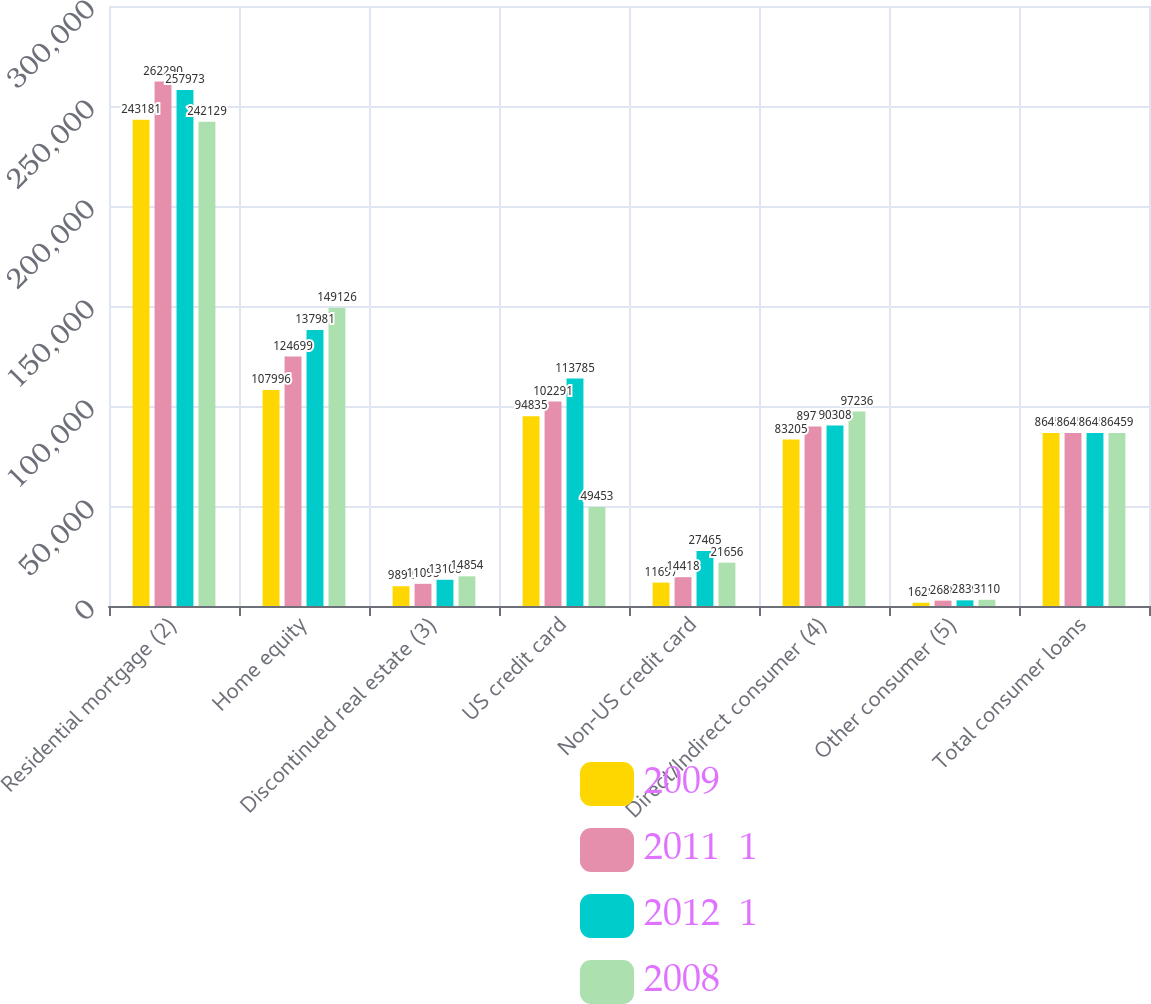<chart> <loc_0><loc_0><loc_500><loc_500><stacked_bar_chart><ecel><fcel>Residential mortgage (2)<fcel>Home equity<fcel>Discontinued real estate (3)<fcel>US credit card<fcel>Non-US credit card<fcel>Direct/Indirect consumer (4)<fcel>Other consumer (5)<fcel>Total consumer loans<nl><fcel>2009<fcel>243181<fcel>107996<fcel>9892<fcel>94835<fcel>11697<fcel>83205<fcel>1628<fcel>86459<nl><fcel>2011  1<fcel>262290<fcel>124699<fcel>11095<fcel>102291<fcel>14418<fcel>89713<fcel>2688<fcel>86459<nl><fcel>2012  1<fcel>257973<fcel>137981<fcel>13108<fcel>113785<fcel>27465<fcel>90308<fcel>2830<fcel>86459<nl><fcel>2008<fcel>242129<fcel>149126<fcel>14854<fcel>49453<fcel>21656<fcel>97236<fcel>3110<fcel>86459<nl></chart> 